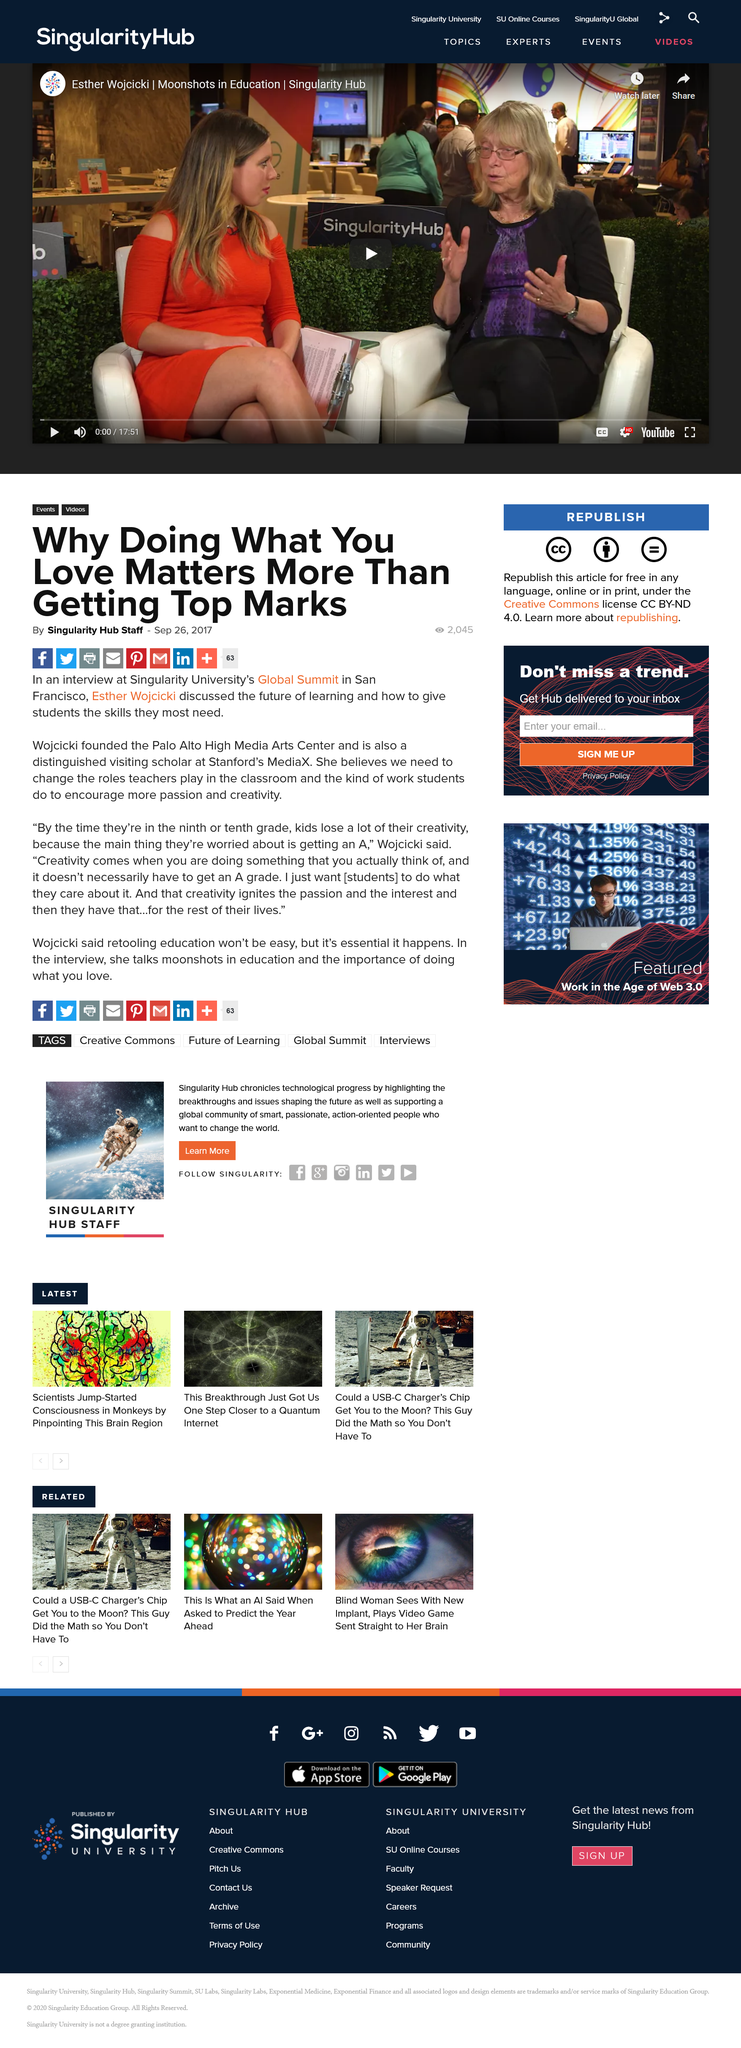Highlight a few significant elements in this photo. The article was written by the Singularity Hub Staff. The article "Why Doing What You Love Matters More Than Getting Top Marks" is shareable on Facebook. The article was published on September 26th, 2017. 